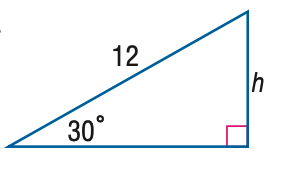Answer the mathemtical geometry problem and directly provide the correct option letter.
Question: Find h.
Choices: A: 3 B: 6 C: 6 \sqrt { 2 } D: 6 \sqrt { 3 } B 